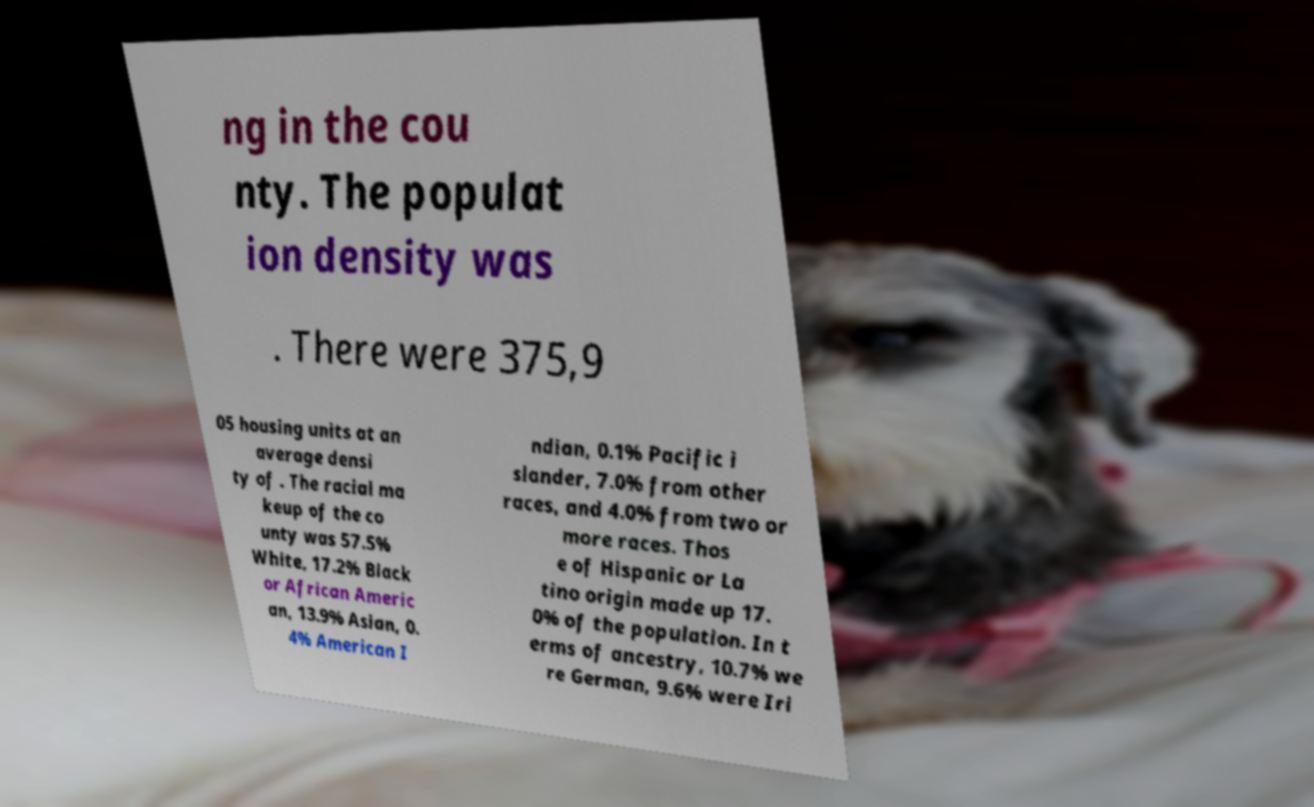There's text embedded in this image that I need extracted. Can you transcribe it verbatim? ng in the cou nty. The populat ion density was . There were 375,9 05 housing units at an average densi ty of . The racial ma keup of the co unty was 57.5% White, 17.2% Black or African Americ an, 13.9% Asian, 0. 4% American I ndian, 0.1% Pacific i slander, 7.0% from other races, and 4.0% from two or more races. Thos e of Hispanic or La tino origin made up 17. 0% of the population. In t erms of ancestry, 10.7% we re German, 9.6% were Iri 